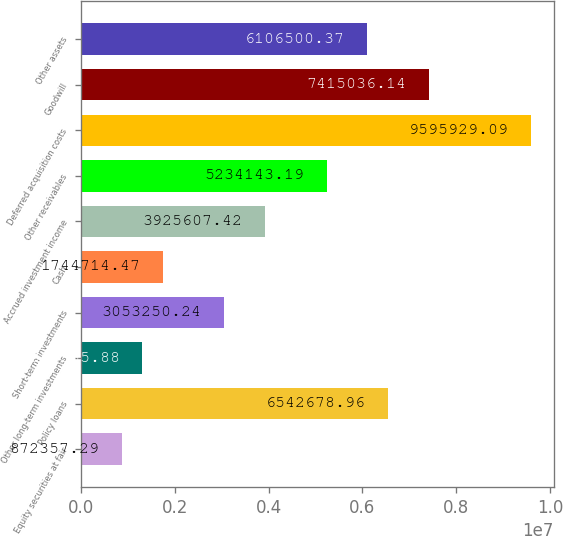Convert chart. <chart><loc_0><loc_0><loc_500><loc_500><bar_chart><fcel>Equity securities at fair<fcel>Policy loans<fcel>Other long-term investments<fcel>Short-term investments<fcel>Cash<fcel>Accrued investment income<fcel>Other receivables<fcel>Deferred acquisition costs<fcel>Goodwill<fcel>Other assets<nl><fcel>872357<fcel>6.54268e+06<fcel>1.30854e+06<fcel>3.05325e+06<fcel>1.74471e+06<fcel>3.92561e+06<fcel>5.23414e+06<fcel>9.59593e+06<fcel>7.41504e+06<fcel>6.1065e+06<nl></chart> 